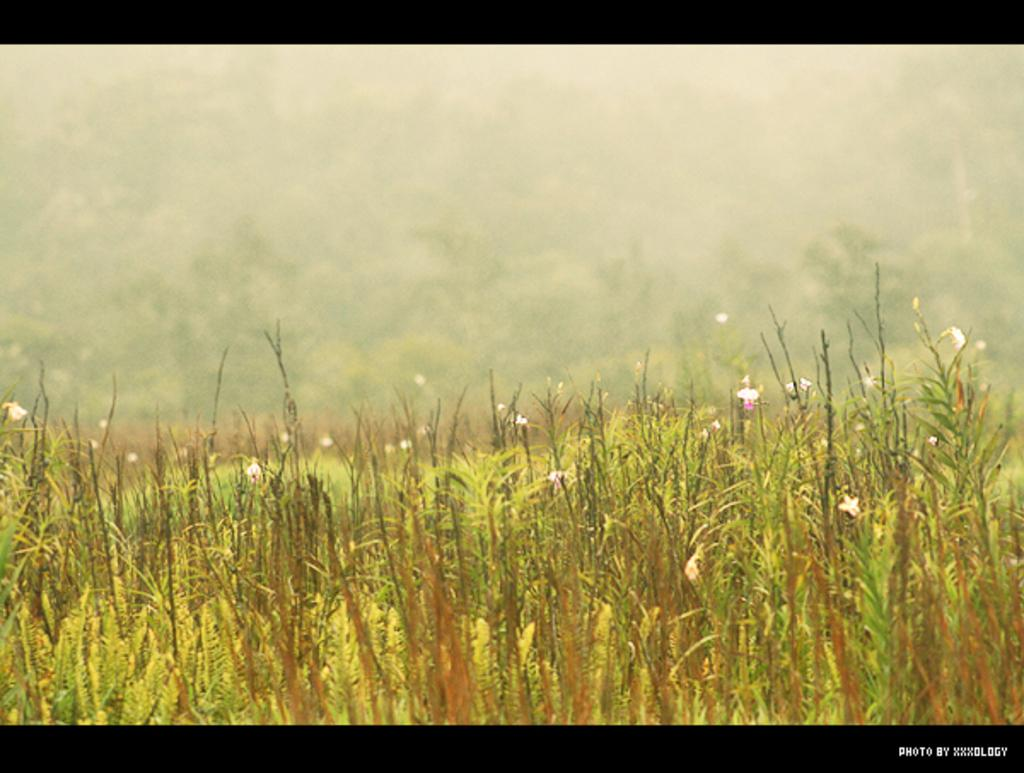What type of living organisms can be seen in the image? Flowers and plants can be seen in the image. Can you describe the plants in the image? The plants in the image are not specified, but they are present alongside the flowers. How many kittens can be seen playing with the flowers in the image? There are no kittens present in the image; it only features flowers and plants. 